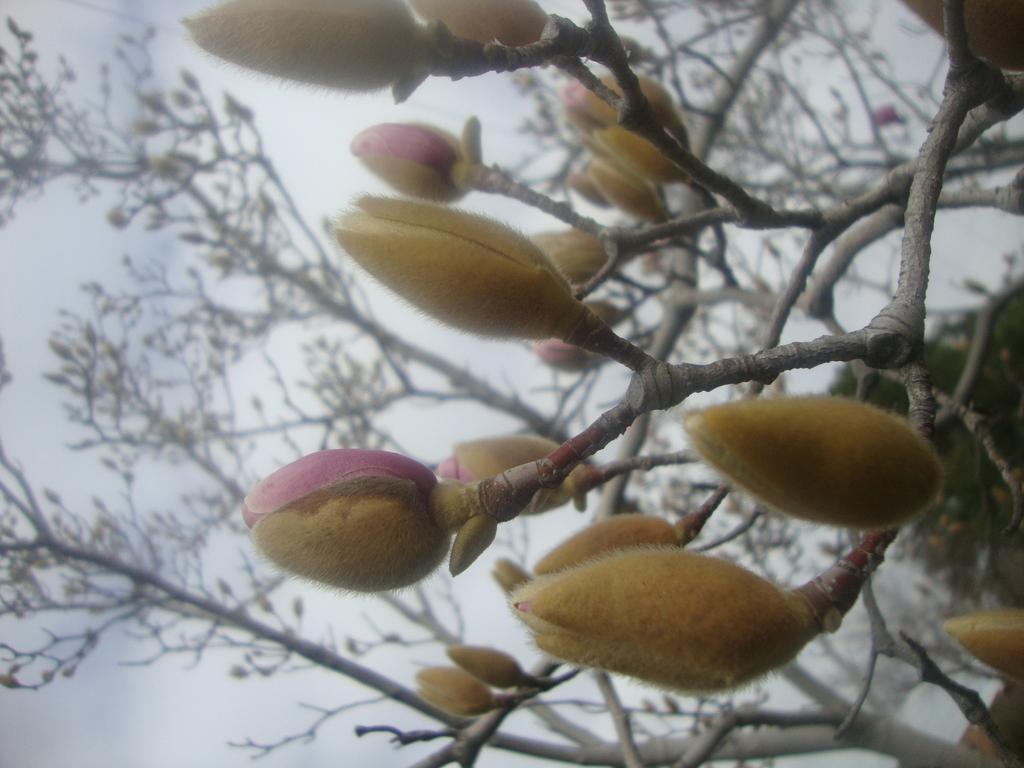How would you summarize this image in a sentence or two? In the picture I can see the flower buds of the plant. In the background, we can see few more plants and the sky. 